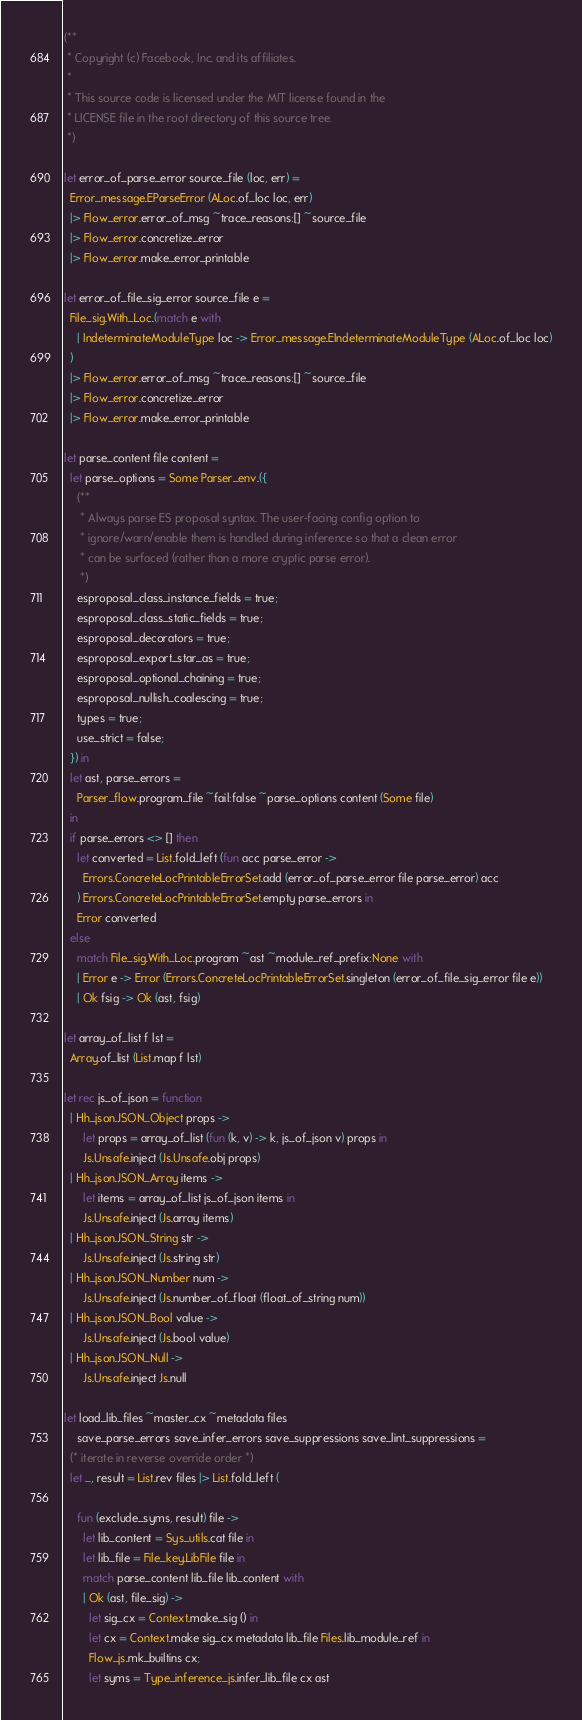<code> <loc_0><loc_0><loc_500><loc_500><_OCaml_>(**
 * Copyright (c) Facebook, Inc. and its affiliates.
 *
 * This source code is licensed under the MIT license found in the
 * LICENSE file in the root directory of this source tree.
 *)

let error_of_parse_error source_file (loc, err) =
  Error_message.EParseError (ALoc.of_loc loc, err)
  |> Flow_error.error_of_msg ~trace_reasons:[] ~source_file
  |> Flow_error.concretize_error
  |> Flow_error.make_error_printable

let error_of_file_sig_error source_file e =
  File_sig.With_Loc.(match e with
    | IndeterminateModuleType loc -> Error_message.EIndeterminateModuleType (ALoc.of_loc loc)
  )
  |> Flow_error.error_of_msg ~trace_reasons:[] ~source_file
  |> Flow_error.concretize_error
  |> Flow_error.make_error_printable

let parse_content file content =
  let parse_options = Some Parser_env.({
    (**
     * Always parse ES proposal syntax. The user-facing config option to
     * ignore/warn/enable them is handled during inference so that a clean error
     * can be surfaced (rather than a more cryptic parse error).
     *)
    esproposal_class_instance_fields = true;
    esproposal_class_static_fields = true;
    esproposal_decorators = true;
    esproposal_export_star_as = true;
    esproposal_optional_chaining = true;
    esproposal_nullish_coalescing = true;
    types = true;
    use_strict = false;
  }) in
  let ast, parse_errors =
    Parser_flow.program_file ~fail:false ~parse_options content (Some file)
  in
  if parse_errors <> [] then
    let converted = List.fold_left (fun acc parse_error ->
      Errors.ConcreteLocPrintableErrorSet.add (error_of_parse_error file parse_error) acc
    ) Errors.ConcreteLocPrintableErrorSet.empty parse_errors in
    Error converted
  else
    match File_sig.With_Loc.program ~ast ~module_ref_prefix:None with
    | Error e -> Error (Errors.ConcreteLocPrintableErrorSet.singleton (error_of_file_sig_error file e))
    | Ok fsig -> Ok (ast, fsig)

let array_of_list f lst =
  Array.of_list (List.map f lst)

let rec js_of_json = function
  | Hh_json.JSON_Object props ->
      let props = array_of_list (fun (k, v) -> k, js_of_json v) props in
      Js.Unsafe.inject (Js.Unsafe.obj props)
  | Hh_json.JSON_Array items ->
      let items = array_of_list js_of_json items in
      Js.Unsafe.inject (Js.array items)
  | Hh_json.JSON_String str ->
      Js.Unsafe.inject (Js.string str)
  | Hh_json.JSON_Number num ->
      Js.Unsafe.inject (Js.number_of_float (float_of_string num))
  | Hh_json.JSON_Bool value ->
      Js.Unsafe.inject (Js.bool value)
  | Hh_json.JSON_Null ->
      Js.Unsafe.inject Js.null

let load_lib_files ~master_cx ~metadata files
    save_parse_errors save_infer_errors save_suppressions save_lint_suppressions =
  (* iterate in reverse override order *)
  let _, result = List.rev files |> List.fold_left (

    fun (exclude_syms, result) file ->
      let lib_content = Sys_utils.cat file in
      let lib_file = File_key.LibFile file in
      match parse_content lib_file lib_content with
      | Ok (ast, file_sig) ->
        let sig_cx = Context.make_sig () in
        let cx = Context.make sig_cx metadata lib_file Files.lib_module_ref in
        Flow_js.mk_builtins cx;
        let syms = Type_inference_js.infer_lib_file cx ast</code> 